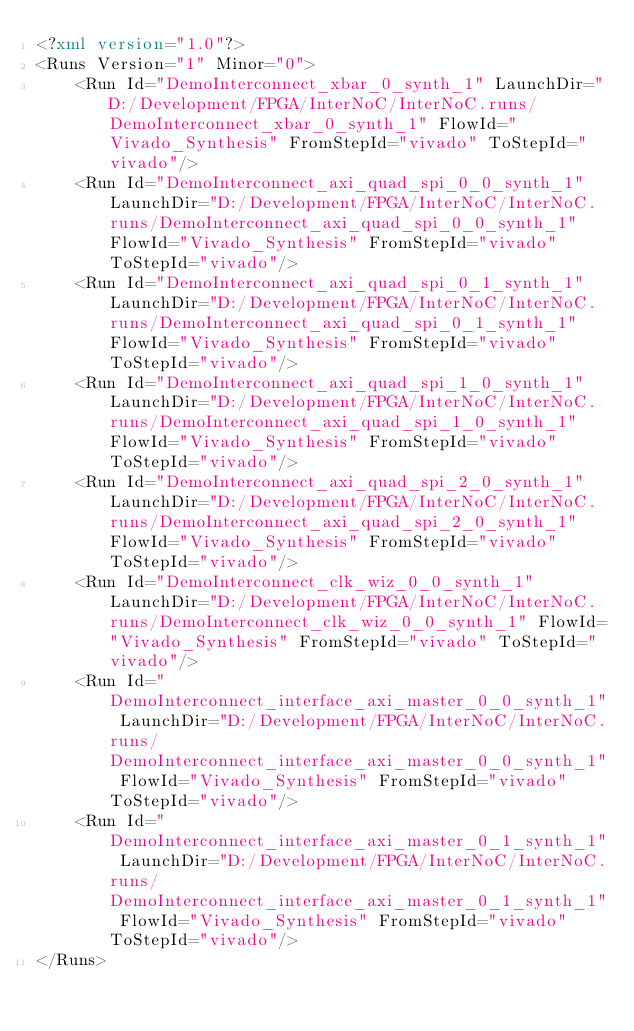Convert code to text. <code><loc_0><loc_0><loc_500><loc_500><_XML_><?xml version="1.0"?>
<Runs Version="1" Minor="0">
	<Run Id="DemoInterconnect_xbar_0_synth_1" LaunchDir="D:/Development/FPGA/InterNoC/InterNoC.runs/DemoInterconnect_xbar_0_synth_1" FlowId="Vivado_Synthesis" FromStepId="vivado" ToStepId="vivado"/>
	<Run Id="DemoInterconnect_axi_quad_spi_0_0_synth_1" LaunchDir="D:/Development/FPGA/InterNoC/InterNoC.runs/DemoInterconnect_axi_quad_spi_0_0_synth_1" FlowId="Vivado_Synthesis" FromStepId="vivado" ToStepId="vivado"/>
	<Run Id="DemoInterconnect_axi_quad_spi_0_1_synth_1" LaunchDir="D:/Development/FPGA/InterNoC/InterNoC.runs/DemoInterconnect_axi_quad_spi_0_1_synth_1" FlowId="Vivado_Synthesis" FromStepId="vivado" ToStepId="vivado"/>
	<Run Id="DemoInterconnect_axi_quad_spi_1_0_synth_1" LaunchDir="D:/Development/FPGA/InterNoC/InterNoC.runs/DemoInterconnect_axi_quad_spi_1_0_synth_1" FlowId="Vivado_Synthesis" FromStepId="vivado" ToStepId="vivado"/>
	<Run Id="DemoInterconnect_axi_quad_spi_2_0_synth_1" LaunchDir="D:/Development/FPGA/InterNoC/InterNoC.runs/DemoInterconnect_axi_quad_spi_2_0_synth_1" FlowId="Vivado_Synthesis" FromStepId="vivado" ToStepId="vivado"/>
	<Run Id="DemoInterconnect_clk_wiz_0_0_synth_1" LaunchDir="D:/Development/FPGA/InterNoC/InterNoC.runs/DemoInterconnect_clk_wiz_0_0_synth_1" FlowId="Vivado_Synthesis" FromStepId="vivado" ToStepId="vivado"/>
	<Run Id="DemoInterconnect_interface_axi_master_0_0_synth_1" LaunchDir="D:/Development/FPGA/InterNoC/InterNoC.runs/DemoInterconnect_interface_axi_master_0_0_synth_1" FlowId="Vivado_Synthesis" FromStepId="vivado" ToStepId="vivado"/>
	<Run Id="DemoInterconnect_interface_axi_master_0_1_synth_1" LaunchDir="D:/Development/FPGA/InterNoC/InterNoC.runs/DemoInterconnect_interface_axi_master_0_1_synth_1" FlowId="Vivado_Synthesis" FromStepId="vivado" ToStepId="vivado"/>
</Runs>

</code> 